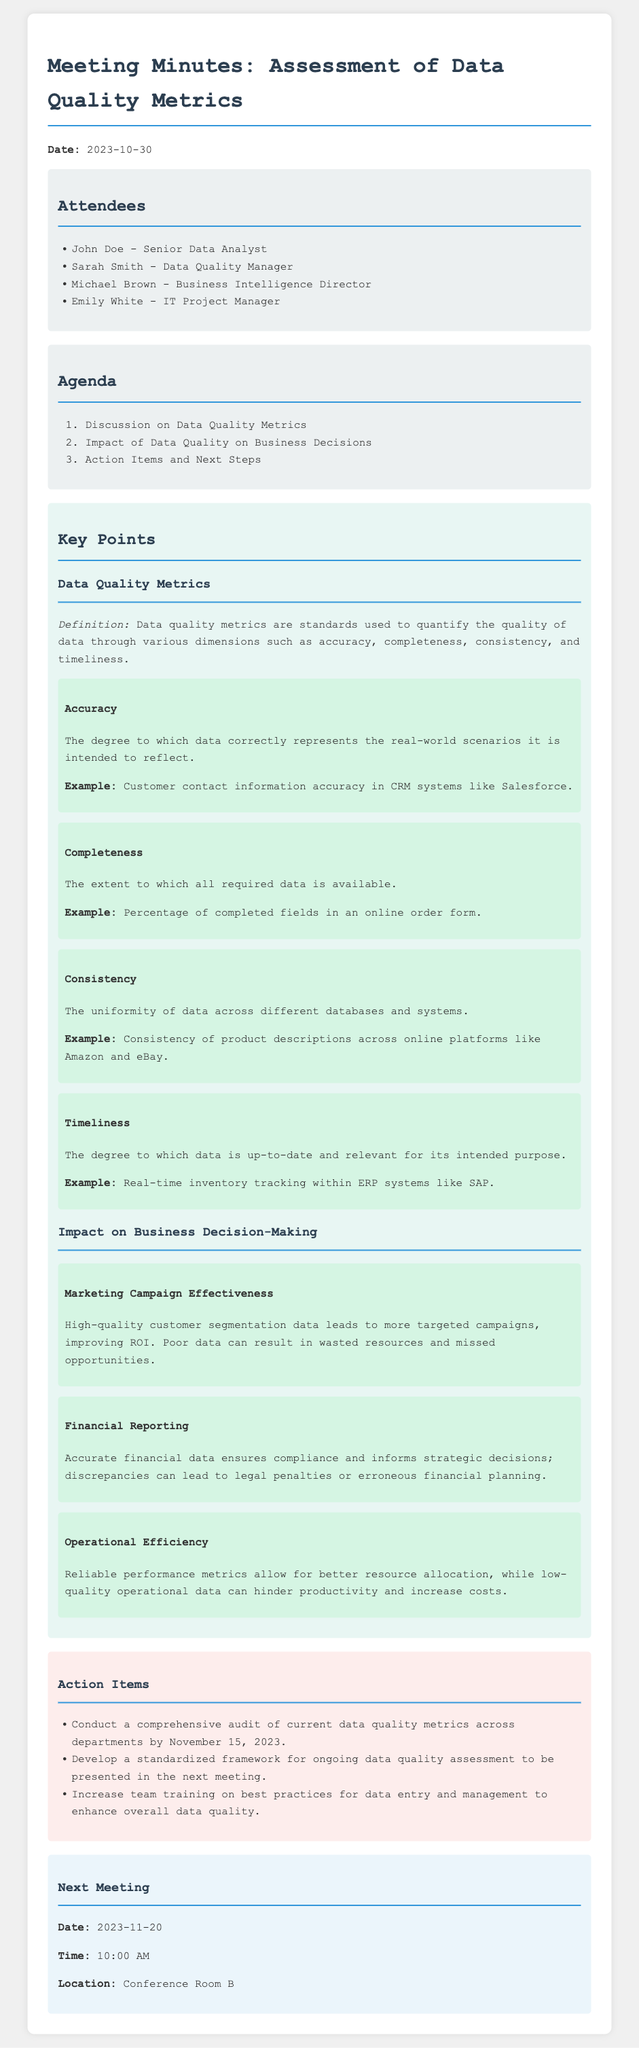what is the date of the meeting? The date of the meeting is specified at the beginning of the document.
Answer: 2023-10-30 who is the Data Quality Manager? The document lists the attendees and their roles, identifying one as the Data Quality Manager.
Answer: Sarah Smith what metric is used to assess the uniformity of data? The document explains the definition of various data quality metrics, including one that focuses on uniformity.
Answer: Consistency by when is the comprehensive audit of current data quality metrics due? The document outlines action items, including a due date for the audit of data quality metrics.
Answer: November 15, 2023 what is one impact of high-quality customer segmentation data? The document discusses the effects of data quality on business decisions, including the benefits of high-quality data in marketing.
Answer: Improving ROI what is the main purpose of the next meeting? The document indicates the purpose of the next meeting through the proposed action items and preparations necessary.
Answer: Presentation of standardized framework what example is given for accuracy in data quality metrics? The document provides specific examples of metrics, including an example related to accuracy.
Answer: Customer contact information accuracy in CRM systems like Salesforce how many attendees are listed in the document? The document provides a list of attendees, indicating how many people were present in the meeting focused on data quality metrics.
Answer: 4 